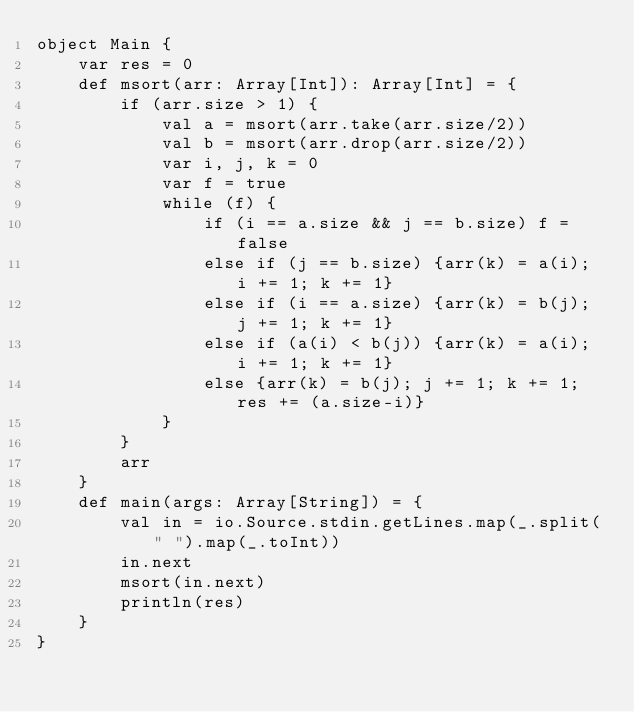Convert code to text. <code><loc_0><loc_0><loc_500><loc_500><_Scala_>object Main {
    var res = 0
    def msort(arr: Array[Int]): Array[Int] = {
        if (arr.size > 1) {
            val a = msort(arr.take(arr.size/2))
            val b = msort(arr.drop(arr.size/2))
            var i, j, k = 0
            var f = true
            while (f) {
                if (i == a.size && j == b.size) f = false
                else if (j == b.size) {arr(k) = a(i); i += 1; k += 1}
                else if (i == a.size) {arr(k) = b(j); j += 1; k += 1}
                else if (a(i) < b(j)) {arr(k) = a(i); i += 1; k += 1}
                else {arr(k) = b(j); j += 1; k += 1; res += (a.size-i)}
            }
        }
        arr
    }
    def main(args: Array[String]) = {
        val in = io.Source.stdin.getLines.map(_.split(" ").map(_.toInt))
        in.next
        msort(in.next)
        println(res)
    }
}</code> 